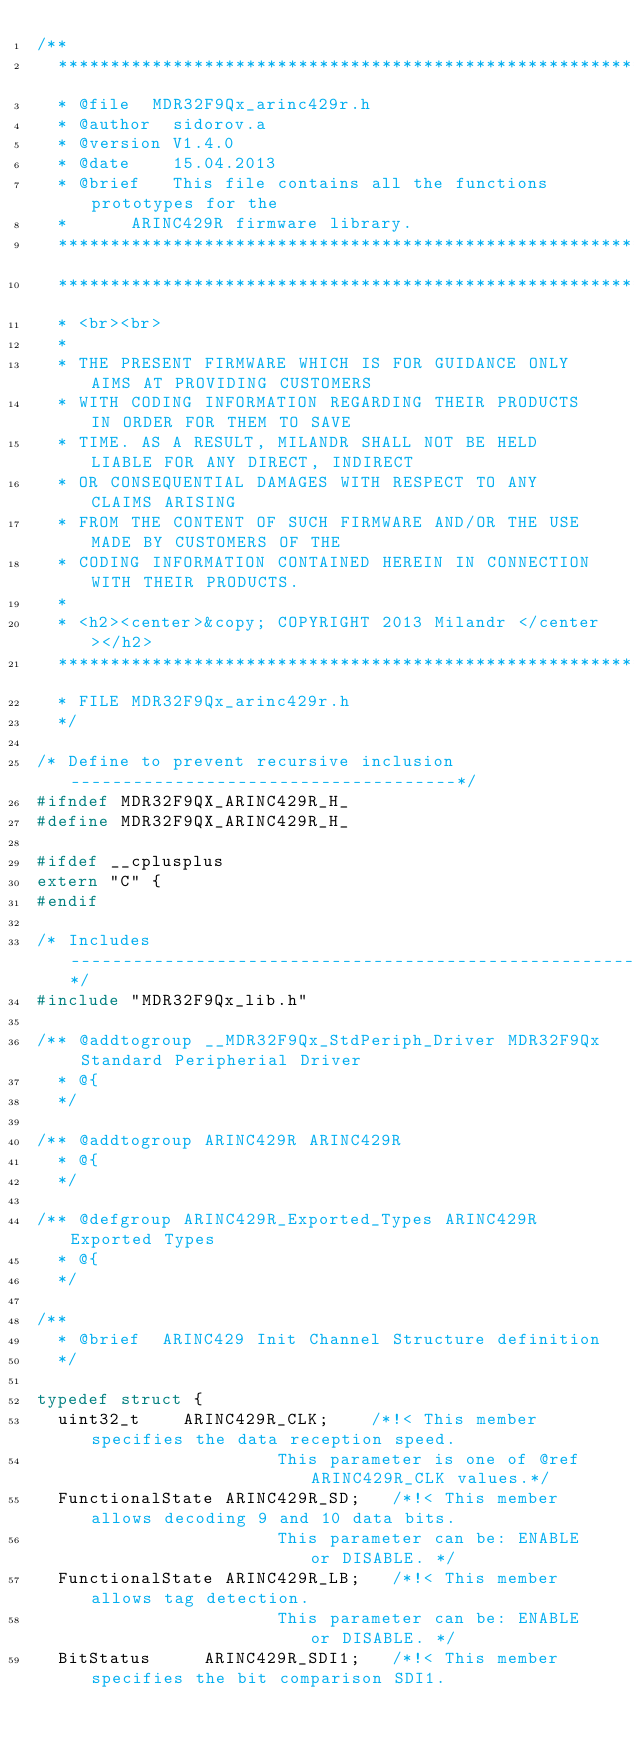Convert code to text. <code><loc_0><loc_0><loc_500><loc_500><_C_>/**
  ******************************************************************************
  * @file	 MDR32F9Qx_arinc429r.h
  * @author	 sidorov.a
  * @version V1.4.0
  * @date    15.04.2013
  * @brief   This file contains all the functions prototypes for the
  * 		 ARINC429R firmware library.
  ******************************************************************************
  ******************************************************************************
  * <br><br>
  *
  * THE PRESENT FIRMWARE WHICH IS FOR GUIDANCE ONLY AIMS AT PROVIDING CUSTOMERS
  * WITH CODING INFORMATION REGARDING THEIR PRODUCTS IN ORDER FOR THEM TO SAVE
  * TIME. AS A RESULT, MILANDR SHALL NOT BE HELD LIABLE FOR ANY DIRECT, INDIRECT
  * OR CONSEQUENTIAL DAMAGES WITH RESPECT TO ANY CLAIMS ARISING
  * FROM THE CONTENT OF SUCH FIRMWARE AND/OR THE USE MADE BY CUSTOMERS OF THE
  * CODING INFORMATION CONTAINED HEREIN IN CONNECTION WITH THEIR PRODUCTS.
  *
  * <h2><center>&copy; COPYRIGHT 2013 Milandr </center></h2>
  ******************************************************************************
  * FILE MDR32F9Qx_arinc429r.h
  */

/* Define to prevent recursive inclusion -------------------------------------*/
#ifndef MDR32F9QX_ARINC429R_H_
#define MDR32F9QX_ARINC429R_H_

#ifdef __cplusplus
extern "C" {
#endif

/* Includes ------------------------------------------------------------------*/
#include "MDR32F9Qx_lib.h"

/** @addtogroup __MDR32F9Qx_StdPeriph_Driver MDR32F9Qx Standard Peripherial Driver
  * @{
  */

/** @addtogroup ARINC429R ARINC429R
  * @{
  */

/** @defgroup ARINC429R_Exported_Types ARINC429R Exported Types
  * @{
  */

/**
  * @brief	ARINC429 Init Channel Structure definition
  */

typedef struct {
	uint32_t 		ARINC429R_CLK;		/*!< This member specifies the data reception speed.
	 	 	 	 	 	 	 	 	 	 	 This parameter is one of @ref ARINC429R_CLK values.*/
	FunctionalState ARINC429R_SD;		/*!< This member allows decoding 9 and 10 data bits.
	 	 	 	 	 	 	 	 	 	 	 This parameter can be: ENABLE or DISABLE. */
	FunctionalState ARINC429R_LB;		/*!< This member allows tag detection.
	 	 	 	 	 	 	 	 	 	 	 This parameter can be: ENABLE or DISABLE. */
	BitStatus 		ARINC429R_SDI1;		/*!< This member specifies the bit comparison SDI1.</code> 